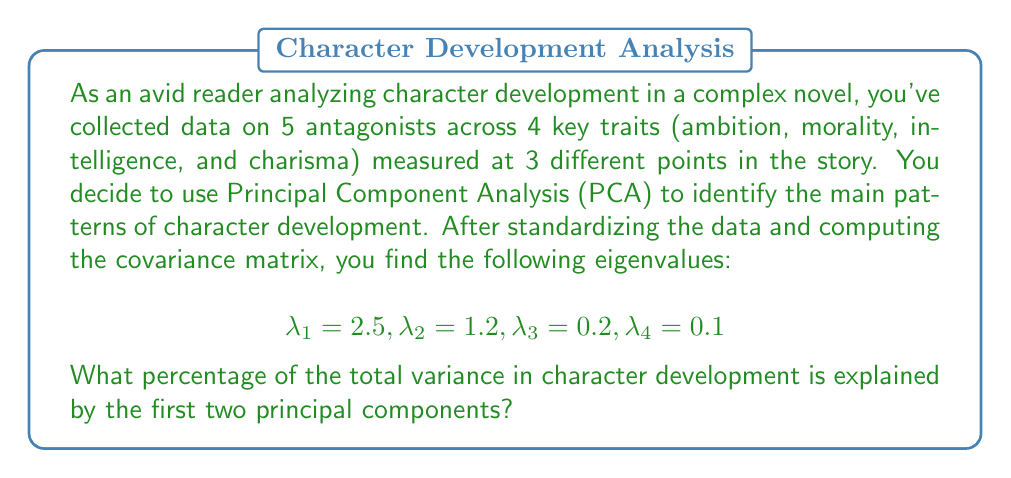Can you solve this math problem? To solve this problem, we'll follow these steps:

1) Recall that in PCA, each eigenvalue represents the amount of variance explained by its corresponding principal component.

2) The total variance is the sum of all eigenvalues:

   $$\text{Total Variance} = \lambda_1 + \lambda_2 + \lambda_3 + \lambda_4 = 2.5 + 1.2 + 0.2 + 0.1 = 4$$

3) The variance explained by the first two principal components is the sum of their eigenvalues:

   $$\text{Variance Explained} = \lambda_1 + \lambda_2 = 2.5 + 1.2 = 3.7$$

4) To calculate the percentage of variance explained, we divide the variance explained by the first two components by the total variance and multiply by 100:

   $$\text{Percentage} = \frac{\text{Variance Explained}}{\text{Total Variance}} \times 100\%$$

   $$= \frac{3.7}{4} \times 100\% = 0.925 \times 100\% = 92.5\%$$

Thus, the first two principal components explain 92.5% of the total variance in character development.
Answer: 92.5% 